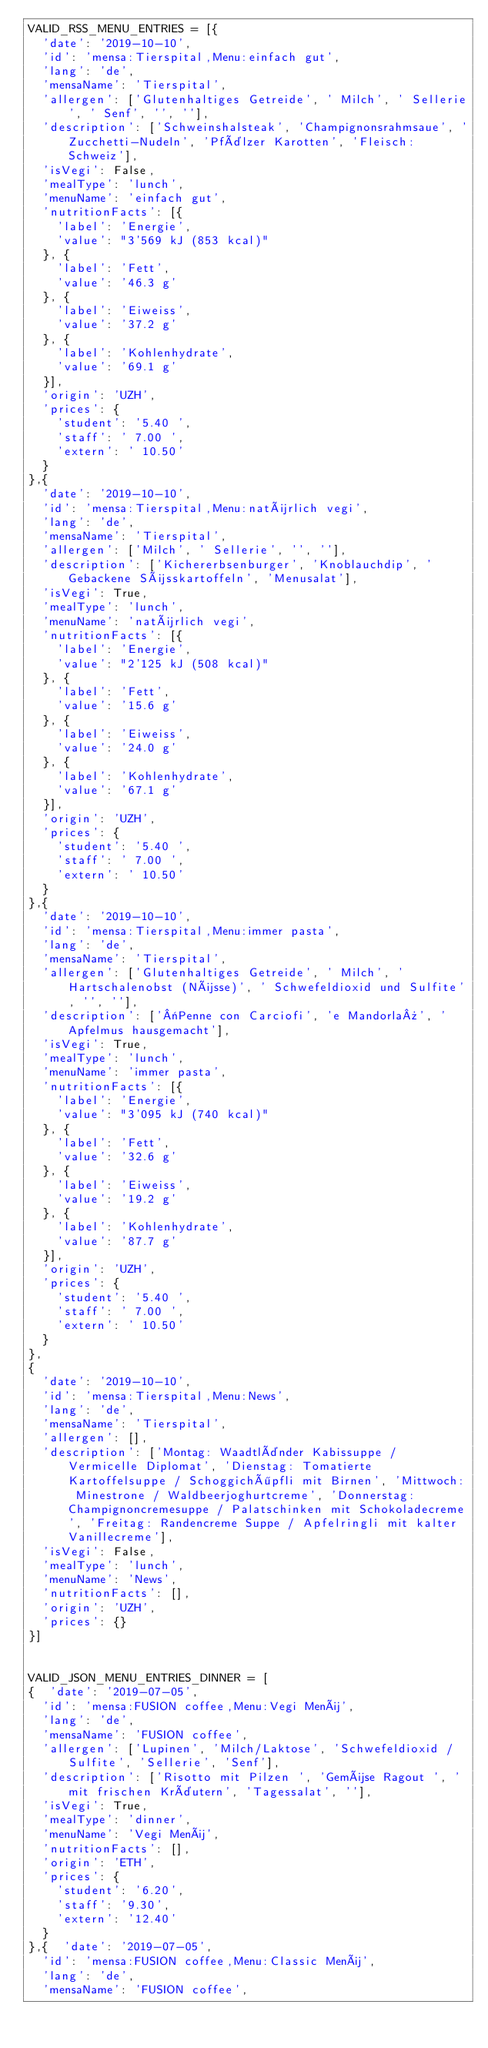Convert code to text. <code><loc_0><loc_0><loc_500><loc_500><_Python_>VALID_RSS_MENU_ENTRIES = [{
  'date': '2019-10-10',
  'id': 'mensa:Tierspital,Menu:einfach gut',
  'lang': 'de',
  'mensaName': 'Tierspital',
  'allergen': ['Glutenhaltiges Getreide', ' Milch', ' Sellerie', ' Senf', '', ''],
  'description': ['Schweinshalsteak', 'Champignonsrahmsaue', 'Zucchetti-Nudeln', 'Pfälzer Karotten', 'Fleisch: Schweiz'],
  'isVegi': False,
  'mealType': 'lunch',
  'menuName': 'einfach gut',
  'nutritionFacts': [{
    'label': 'Energie',
    'value': "3'569 kJ (853 kcal)"
  }, {
    'label': 'Fett',
    'value': '46.3 g'
  }, {
    'label': 'Eiweiss',
    'value': '37.2 g'
  }, {
    'label': 'Kohlenhydrate',
    'value': '69.1 g'
  }],
  'origin': 'UZH',
  'prices': {
    'student': '5.40 ',
    'staff': ' 7.00 ',
    'extern': ' 10.50'
  }
},{
  'date': '2019-10-10',
  'id': 'mensa:Tierspital,Menu:natürlich vegi',
  'lang': 'de',
  'mensaName': 'Tierspital',
  'allergen': ['Milch', ' Sellerie', '', ''],
  'description': ['Kichererbsenburger', 'Knoblauchdip', 'Gebackene Süsskartoffeln', 'Menusalat'],
  'isVegi': True,
  'mealType': 'lunch',
  'menuName': 'natürlich vegi',
  'nutritionFacts': [{
    'label': 'Energie',
    'value': "2'125 kJ (508 kcal)"
  }, {
    'label': 'Fett',
    'value': '15.6 g'
  }, {
    'label': 'Eiweiss',
    'value': '24.0 g'
  }, {
    'label': 'Kohlenhydrate',
    'value': '67.1 g'
  }],
  'origin': 'UZH',
  'prices': {
    'student': '5.40 ',
    'staff': ' 7.00 ',
    'extern': ' 10.50'
  }
},{
  'date': '2019-10-10',
  'id': 'mensa:Tierspital,Menu:immer pasta',
  'lang': 'de',
  'mensaName': 'Tierspital',
  'allergen': ['Glutenhaltiges Getreide', ' Milch', ' Hartschalenobst (Nüsse)', ' Schwefeldioxid und Sulfite', '', ''],
  'description': ['«Penne con Carciofi', 'e Mandorla»', 'Apfelmus hausgemacht'],
  'isVegi': True,
  'mealType': 'lunch',
  'menuName': 'immer pasta',
  'nutritionFacts': [{
    'label': 'Energie',
    'value': "3'095 kJ (740 kcal)"
  }, {
    'label': 'Fett',
    'value': '32.6 g'
  }, {
    'label': 'Eiweiss',
    'value': '19.2 g'
  }, {
    'label': 'Kohlenhydrate',
    'value': '87.7 g'
  }],
  'origin': 'UZH',
  'prices': {
    'student': '5.40 ',
    'staff': ' 7.00 ',
    'extern': ' 10.50'
  }
},
{
  'date': '2019-10-10',
  'id': 'mensa:Tierspital,Menu:News',
  'lang': 'de',
  'mensaName': 'Tierspital',
  'allergen': [],
  'description': ['Montag: Waadtländer Kabissuppe / Vermicelle Diplomat', 'Dienstag: Tomatierte Kartoffelsuppe / Schoggichöpfli mit Birnen', 'Mittwoch: Minestrone / Waldbeerjoghurtcreme', 'Donnerstag: Champignoncremesuppe / Palatschinken mit Schokoladecreme', 'Freitag: Randencreme Suppe / Apfelringli mit kalter Vanillecreme'],
  'isVegi': False,
  'mealType': 'lunch',
  'menuName': 'News',
  'nutritionFacts': [],
  'origin': 'UZH',
  'prices': {}
}]


VALID_JSON_MENU_ENTRIES_DINNER = [
{  'date': '2019-07-05',
  'id': 'mensa:FUSION coffee,Menu:Vegi Menü',
  'lang': 'de',
  'mensaName': 'FUSION coffee',
  'allergen': ['Lupinen', 'Milch/Laktose', 'Schwefeldioxid / Sulfite', 'Sellerie', 'Senf'],
  'description': ['Risotto mit Pilzen ', 'Gemüse Ragout ', 'mit frischen Kräutern', 'Tagessalat', ''],
  'isVegi': True,
  'mealType': 'dinner',
  'menuName': 'Vegi Menü',
  'nutritionFacts': [],
  'origin': 'ETH',
  'prices': {
    'student': '6.20',
    'staff': '9.30',
    'extern': '12.40'
  }
},{  'date': '2019-07-05',
  'id': 'mensa:FUSION coffee,Menu:Classic Menü',
  'lang': 'de',
  'mensaName': 'FUSION coffee',</code> 